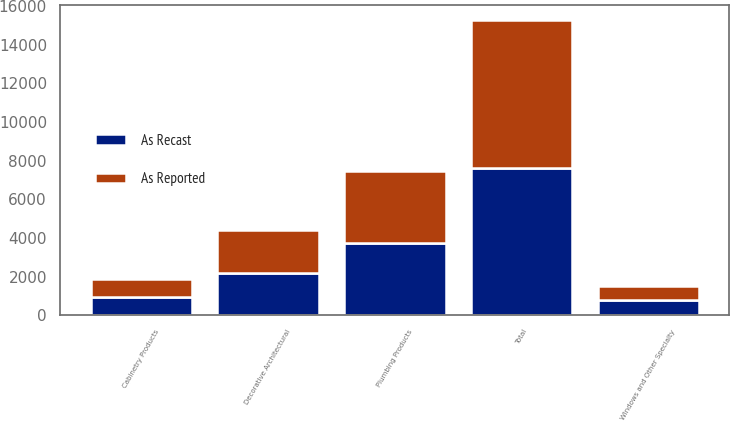Convert chart to OTSL. <chart><loc_0><loc_0><loc_500><loc_500><stacked_bar_chart><ecel><fcel>Plumbing Products<fcel>Decorative Architectural<fcel>Cabinetry Products<fcel>Windows and Other Specialty<fcel>Total<nl><fcel>As Reported<fcel>3735<fcel>2205<fcel>934<fcel>770<fcel>7644<nl><fcel>As Recast<fcel>3732<fcel>2206<fcel>934<fcel>770<fcel>7642<nl></chart> 